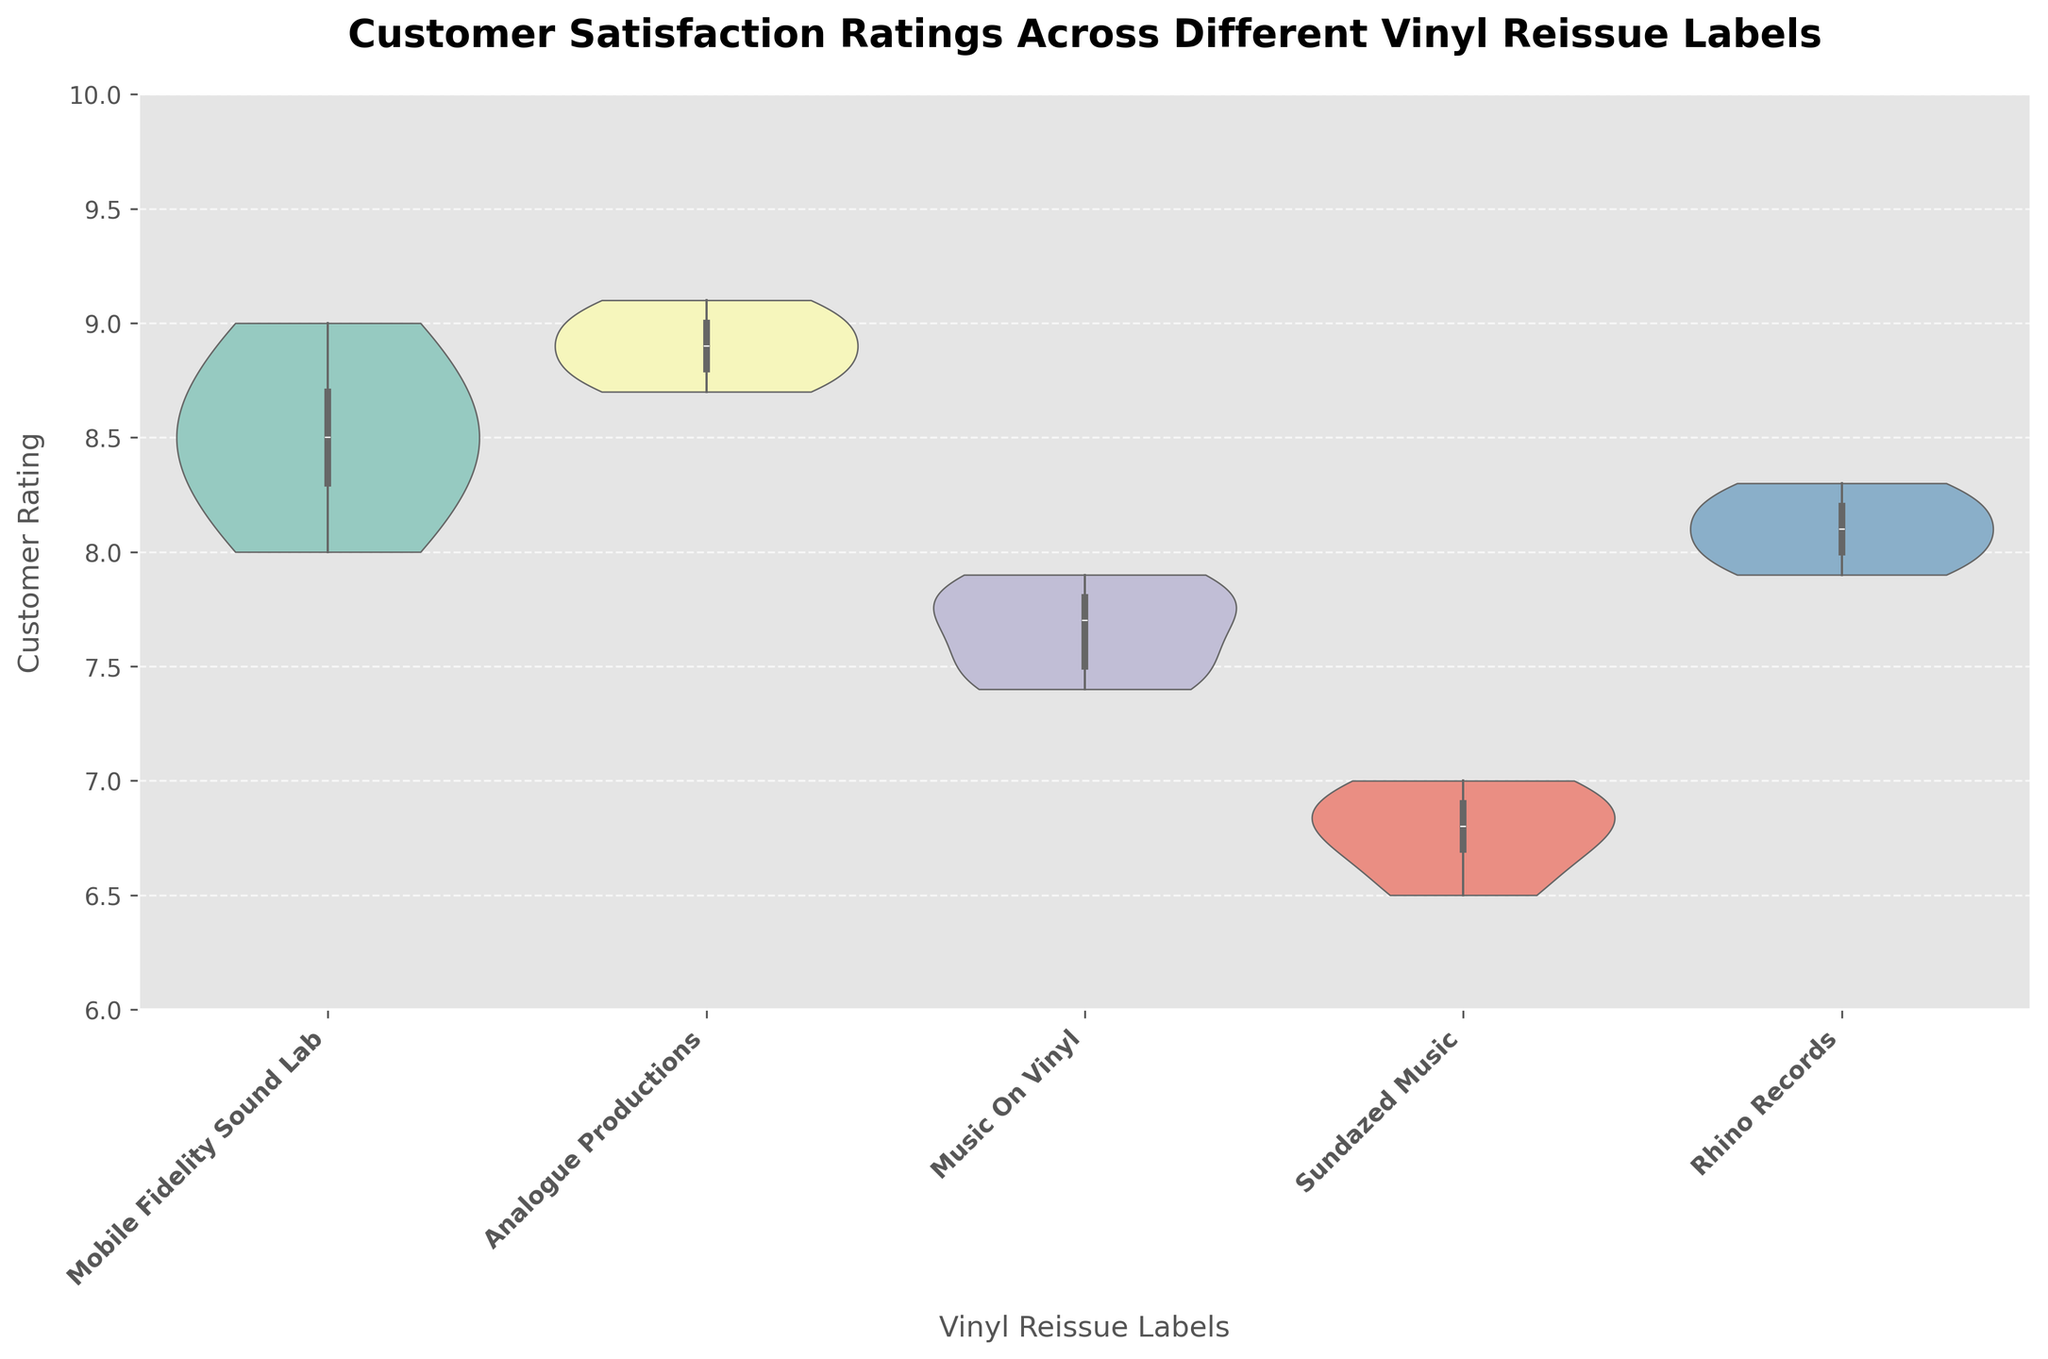What's the title of the chart? The title is located at the top of the chart and can be seen in bold text.
Answer: Customer Satisfaction Ratings Across Different Vinyl Reissue Labels Which vinyl reissue label has the highest median customer rating? By observing the central thick line in each of the violins, Analogue Productions shows the highest median rating.
Answer: Analogue Productions Which label has the widest range of customer ratings? The horizontal width of the violins indicates data density. Sundazed Music spans from 6.5 to 7.0, which is the widest range.
Answer: Sundazed Music What is the lowest customer rating for Sundazed Music? The lowest point of the violin for Sundazed Music is located at 6.5.
Answer: 6.5 How many labels have a median customer rating above 8.0? By observing the central thick lines of each violin, we can see that Mobile Fidelity Sound Lab, Analogue Productions, and Rhino Records all have a median above 8.0.
Answer: 3 Compare the interquartile ranges of Mobile Fidelity Sound Lab and Music On Vinyl. Which is larger? The interquartile range is indicated by the span of the thicker part of the violin. Mobile Fidelity Sound Lab's interquartile range appears larger compared to Music On Vinyl.
Answer: Mobile Fidelity Sound Lab What is the median customer rating for Rhino Records? The central thick line in Rhino Records' violin indicates the median, which is approximately 8.1.
Answer: 8.1 Which label shows the most uniform distribution of customer ratings? A uniform distribution would have a fairly even width throughout the violin. Rhino Records' violin is relatively uniform.
Answer: Rhino Records What's the average rating for Analogue Productions? The average can be approximated by the balance of the violin plot centering around 8.9.
Answer: Approximately 8.9 Of the labels listed, which one has the narrowest range of customer ratings? By observing the width of the violin plots, Analogue Productions has the narrowest range from roughly 8.7 to 9.1.
Answer: Analogue Productions 